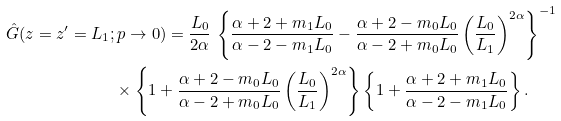<formula> <loc_0><loc_0><loc_500><loc_500>\hat { G } ( z = z ^ { \prime } = L _ { 1 } ; & \, p \rightarrow 0 ) = \frac { L _ { 0 } } { 2 \alpha } \, \left \{ \frac { \alpha + 2 + m _ { 1 } L _ { 0 } } { \alpha - 2 - m _ { 1 } L _ { 0 } } - \frac { \alpha + 2 - m _ { 0 } L _ { 0 } } { \alpha - 2 + m _ { 0 } L _ { 0 } } \left ( \frac { L _ { 0 } } { L _ { 1 } } \right ) ^ { 2 \alpha } \right \} ^ { - 1 } \\ & \times \left \{ 1 + \frac { \alpha + 2 - m _ { 0 } L _ { 0 } } { \alpha - 2 + m _ { 0 } L _ { 0 } } \left ( \frac { L _ { 0 } } { L _ { 1 } } \right ) ^ { 2 \alpha } \right \} \left \{ 1 + \frac { \alpha + 2 + m _ { 1 } L _ { 0 } } { \alpha - 2 - m _ { 1 } L _ { 0 } } \right \} .</formula> 